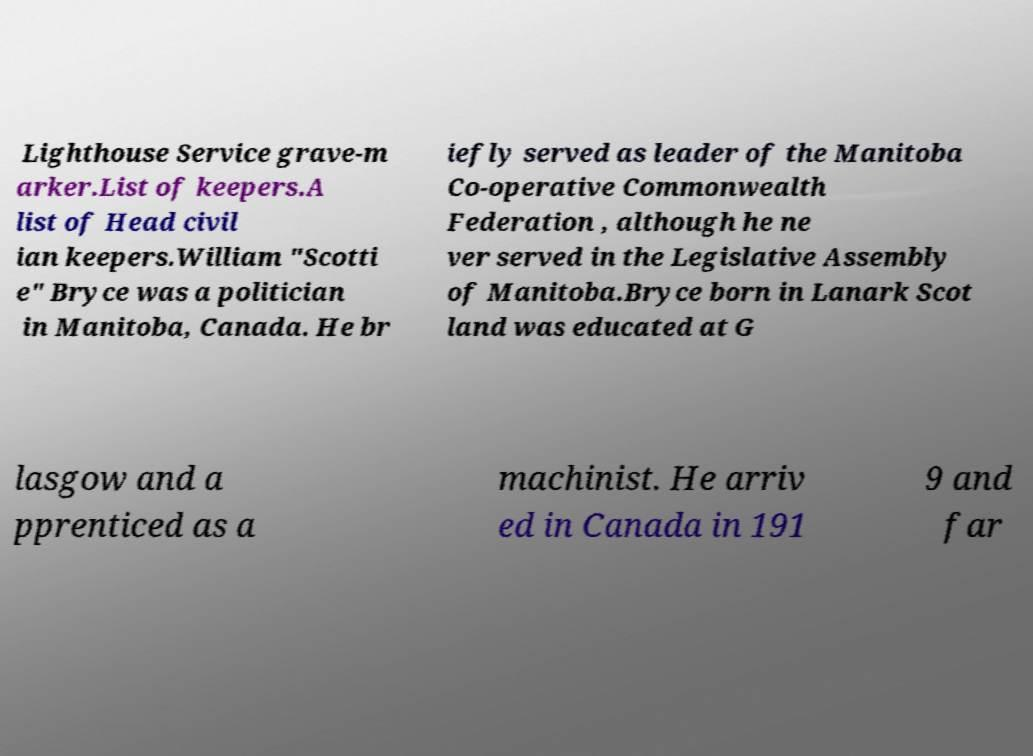What messages or text are displayed in this image? I need them in a readable, typed format. Lighthouse Service grave-m arker.List of keepers.A list of Head civil ian keepers.William "Scotti e" Bryce was a politician in Manitoba, Canada. He br iefly served as leader of the Manitoba Co-operative Commonwealth Federation , although he ne ver served in the Legislative Assembly of Manitoba.Bryce born in Lanark Scot land was educated at G lasgow and a pprenticed as a machinist. He arriv ed in Canada in 191 9 and far 